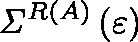Convert formula to latex. <formula><loc_0><loc_0><loc_500><loc_500>{ \Sigma } ^ { R \left ( A \right ) } \left ( \varepsilon \right )</formula> 